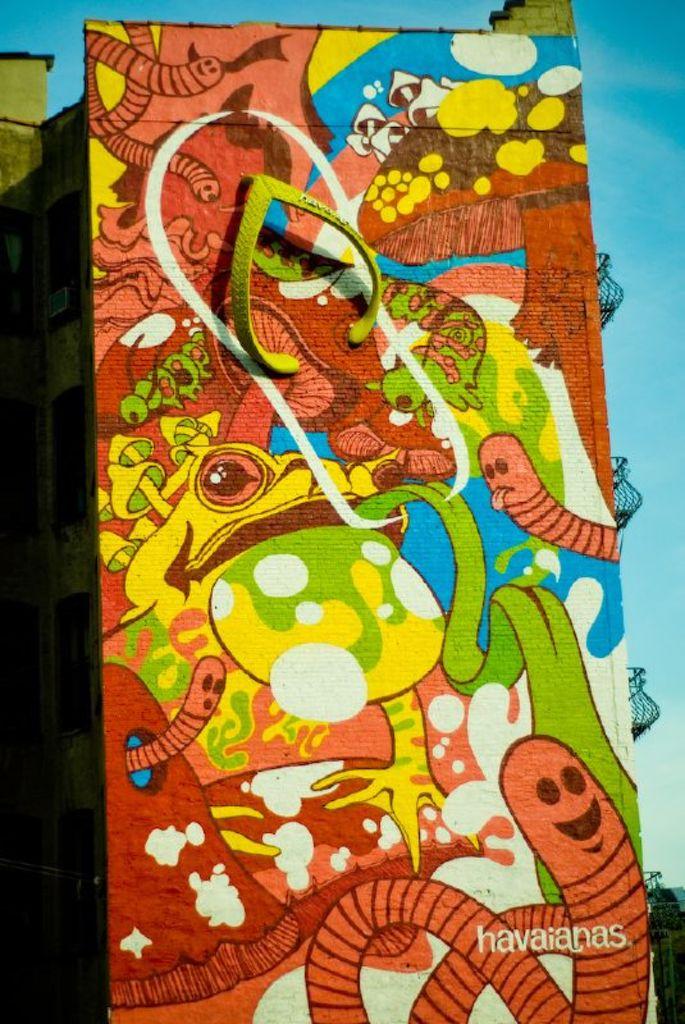What name is written on the bottom right of the ad?
Make the answer very short. Havaianas. 